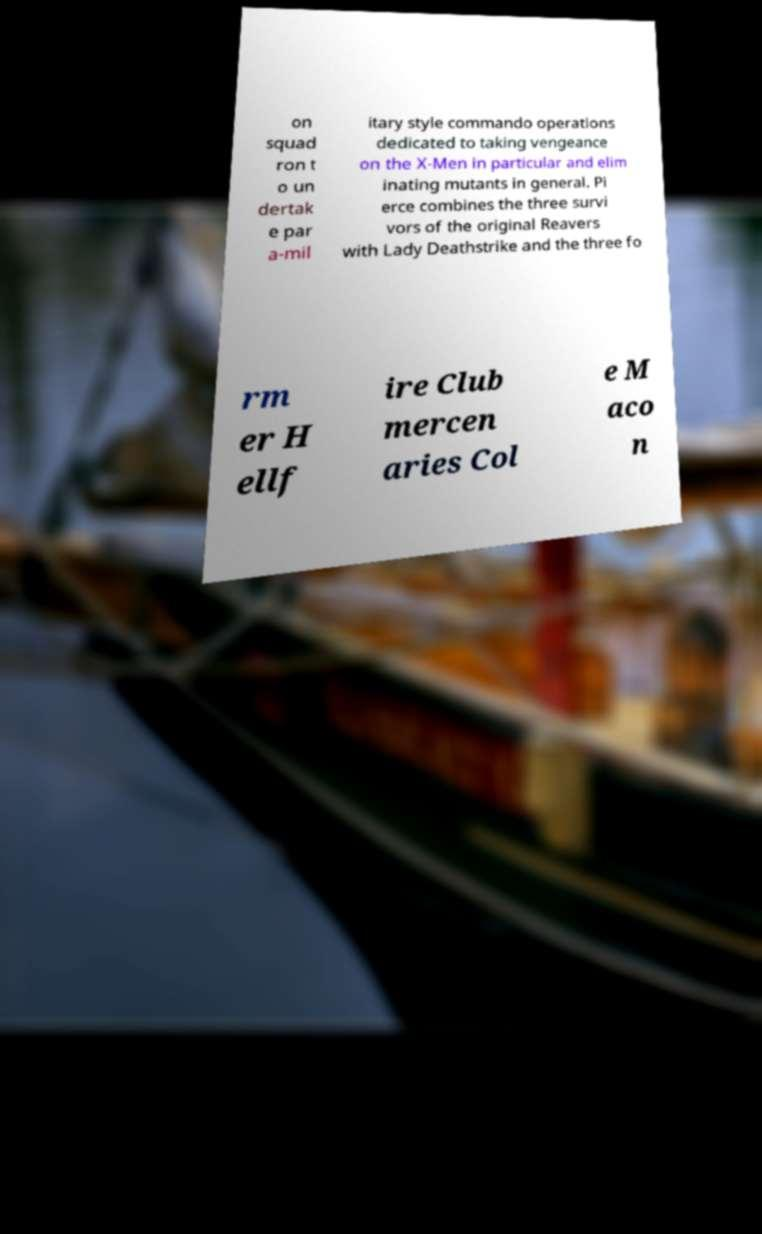There's text embedded in this image that I need extracted. Can you transcribe it verbatim? on squad ron t o un dertak e par a-mil itary style commando operations dedicated to taking vengeance on the X-Men in particular and elim inating mutants in general. Pi erce combines the three survi vors of the original Reavers with Lady Deathstrike and the three fo rm er H ellf ire Club mercen aries Col e M aco n 